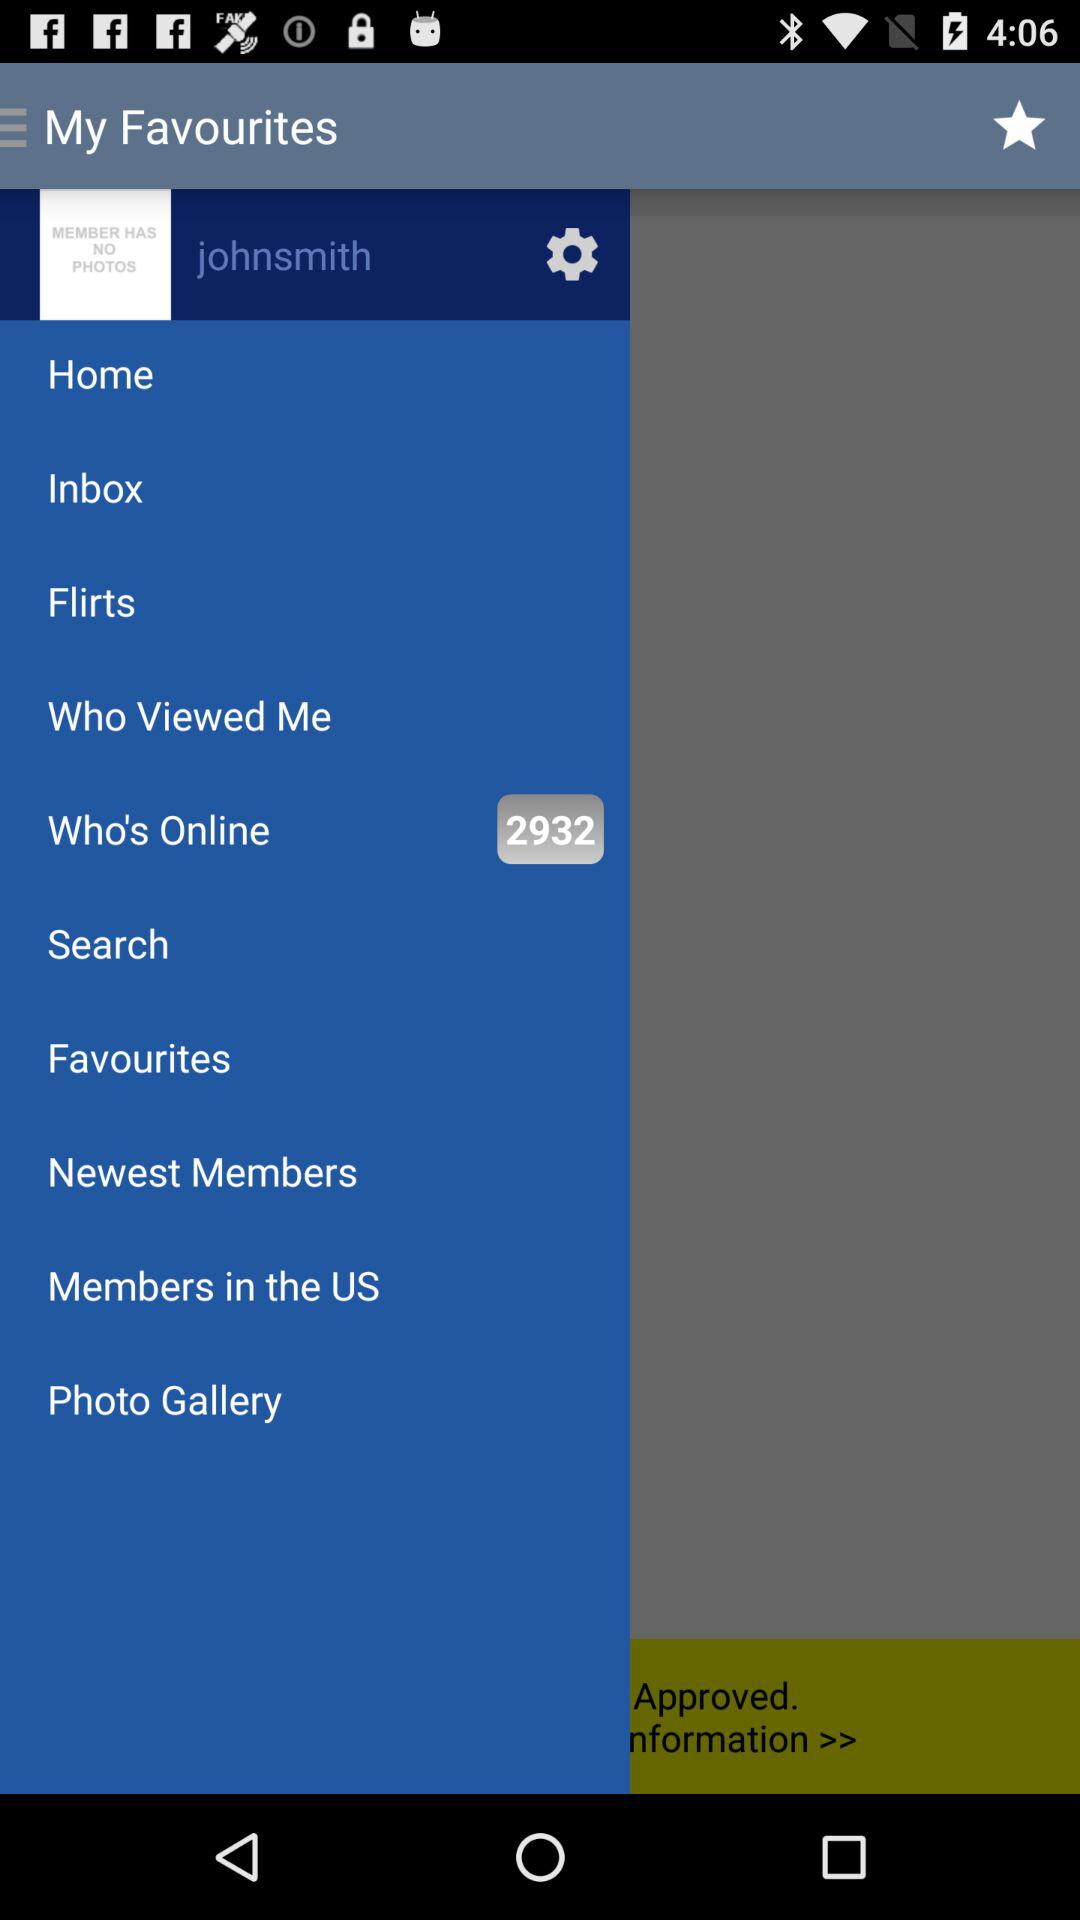How many users are online? There are 2932 users online. 